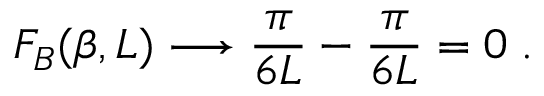Convert formula to latex. <formula><loc_0><loc_0><loc_500><loc_500>F _ { B } ( \beta , L ) \longrightarrow \frac { \pi } { 6 L } - \frac { \pi } { 6 L } = 0 \, .</formula> 